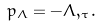<formula> <loc_0><loc_0><loc_500><loc_500>p _ { \Lambda } = - \Lambda , _ { \tau } .</formula> 